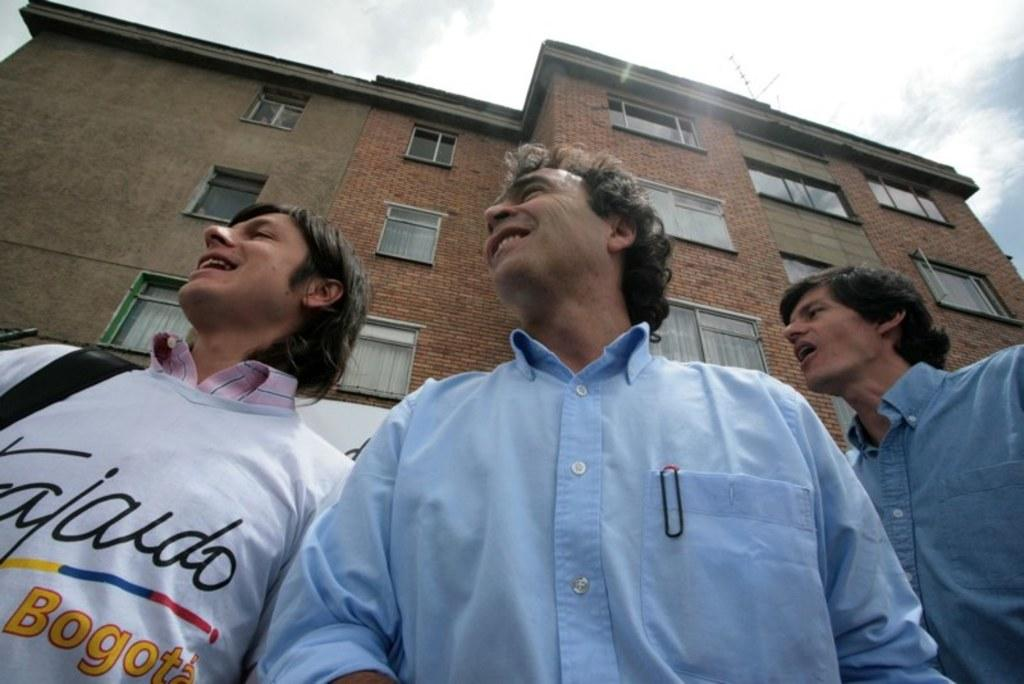How many people are present in the image? There are three people standing in the image. What can be seen in the background of the image? There is a building and the sky visible in the background of the image. What type of art is being created by the people in the image? There is no indication in the image that the people are creating art, so it cannot be determined from the picture. 